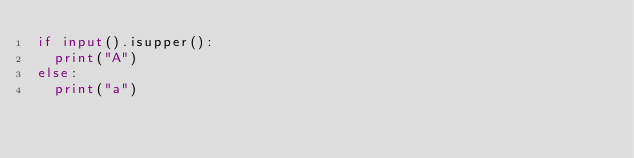Convert code to text. <code><loc_0><loc_0><loc_500><loc_500><_Python_>if input().isupper():
  print("A")
else:
  print("a")</code> 